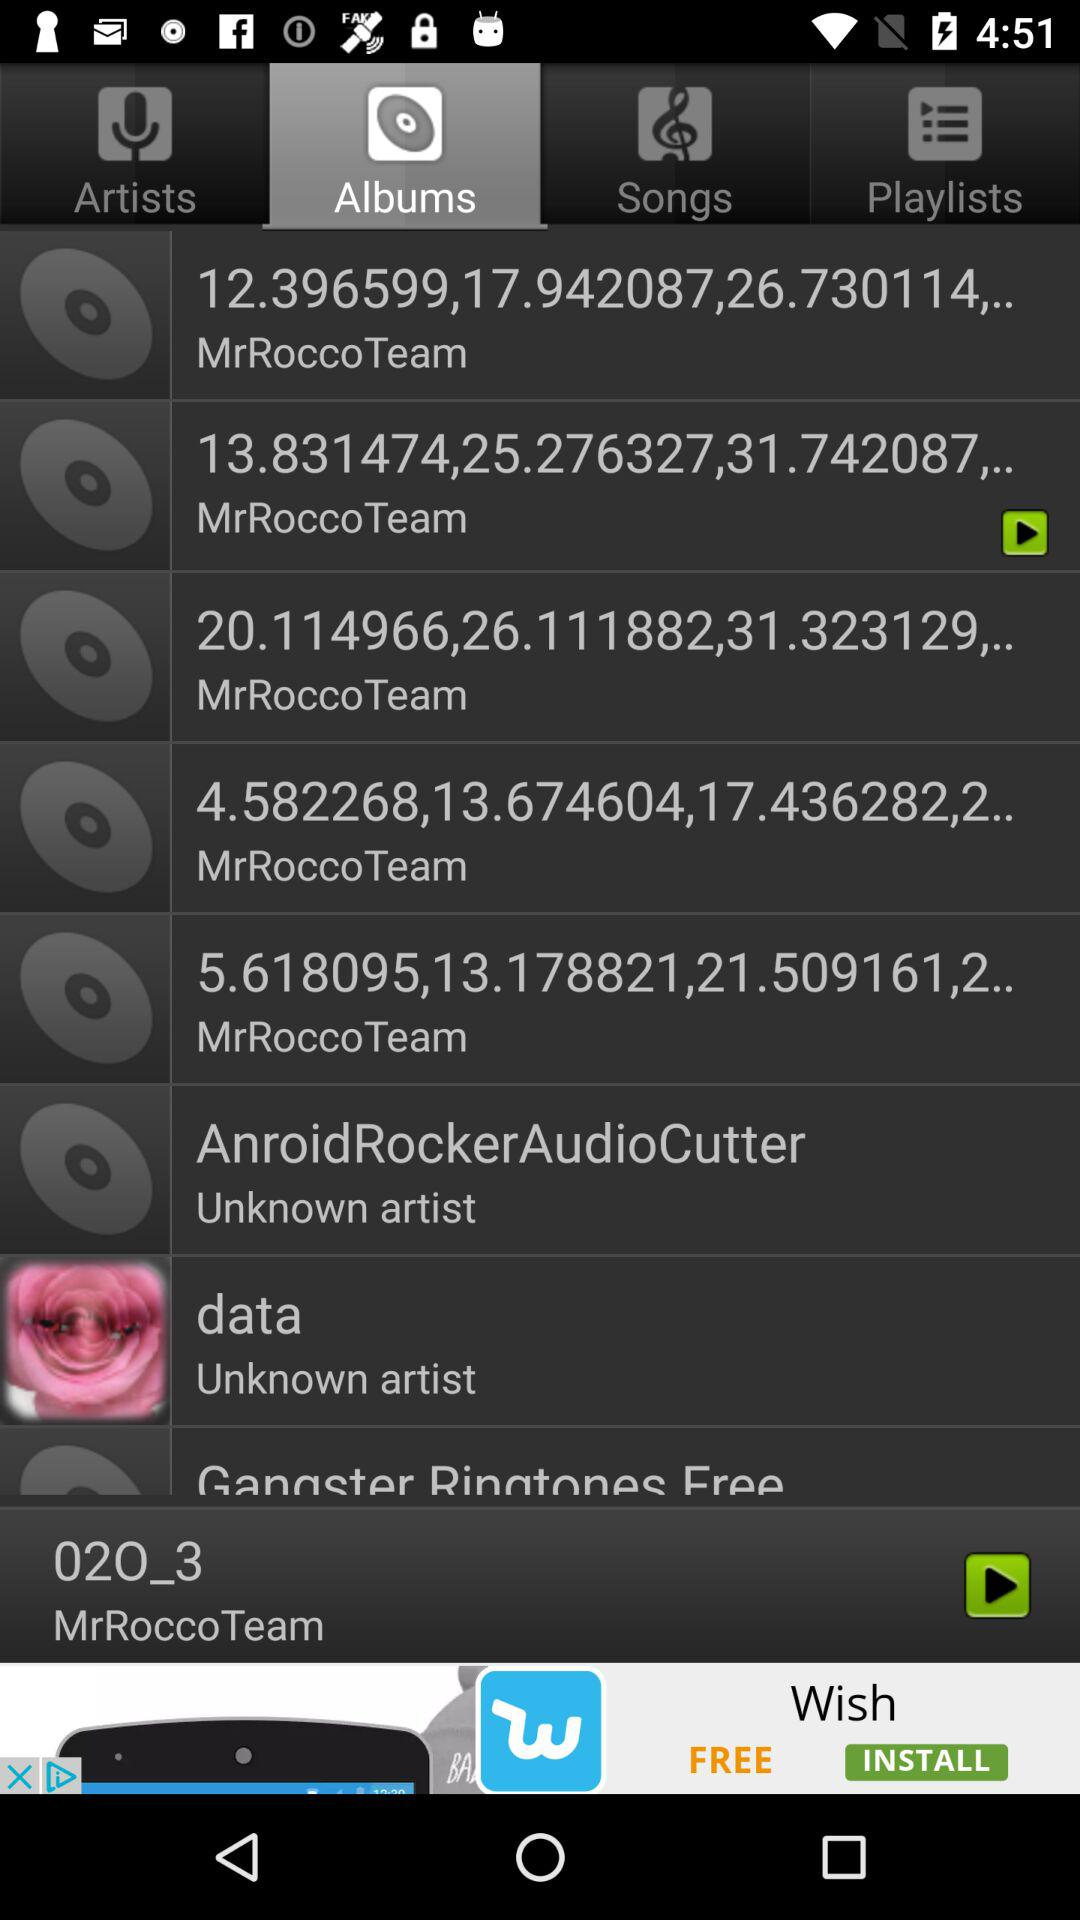Which tab is selected? The selected tab is "Albums". 